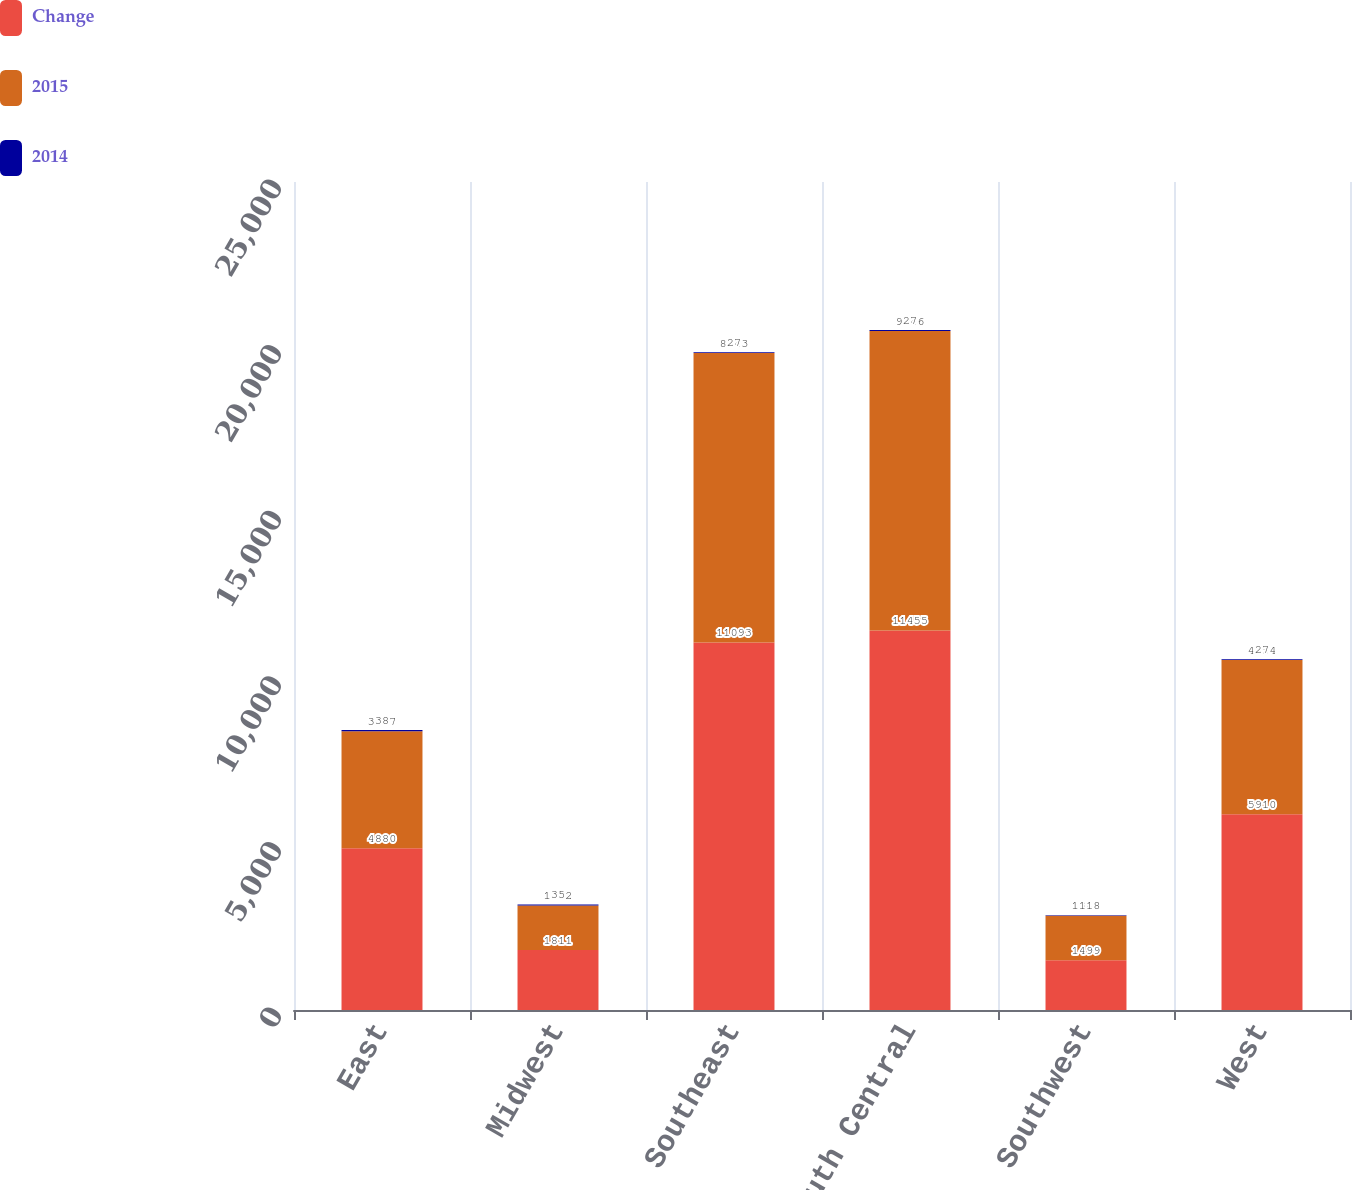<chart> <loc_0><loc_0><loc_500><loc_500><stacked_bar_chart><ecel><fcel>East<fcel>Midwest<fcel>Southeast<fcel>South Central<fcel>Southwest<fcel>West<nl><fcel>Change<fcel>4880<fcel>1811<fcel>11093<fcel>11455<fcel>1499<fcel>5910<nl><fcel>2015<fcel>3537<fcel>1342<fcel>8743<fcel>9046<fcel>1348<fcel>4654<nl><fcel>2014<fcel>38<fcel>35<fcel>27<fcel>27<fcel>11<fcel>27<nl></chart> 